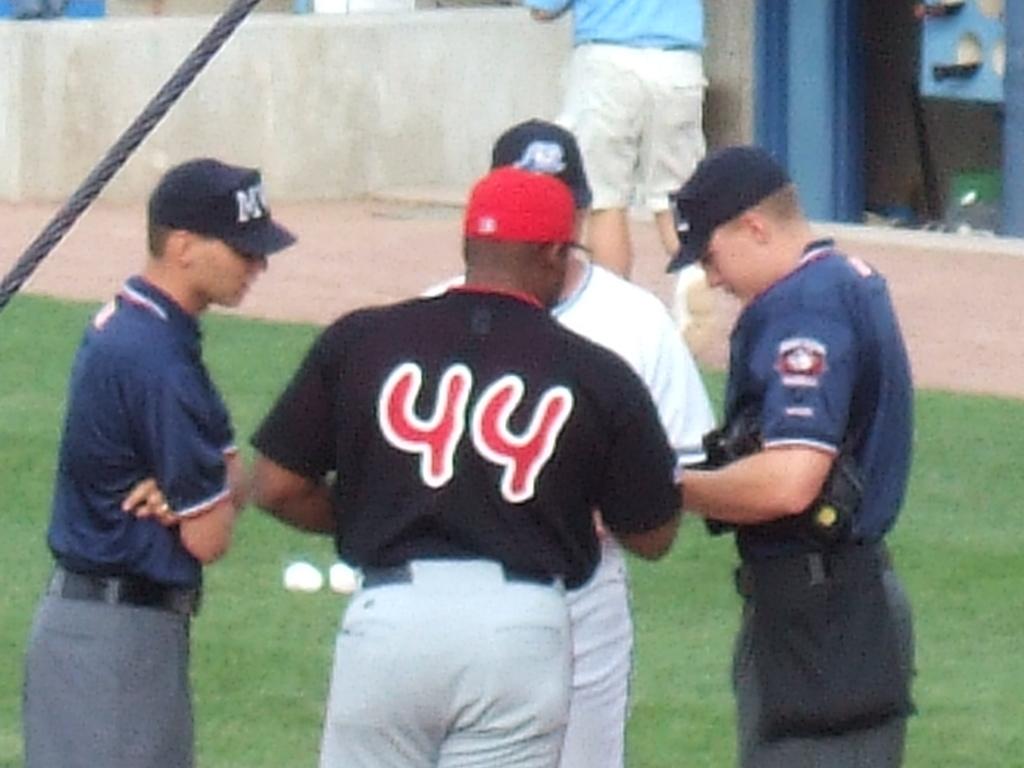What number is this baseball player wearing on his jersey?
Give a very brief answer. 44. What letter is visible on the hat on the man on the left?
Provide a succinct answer. M. 